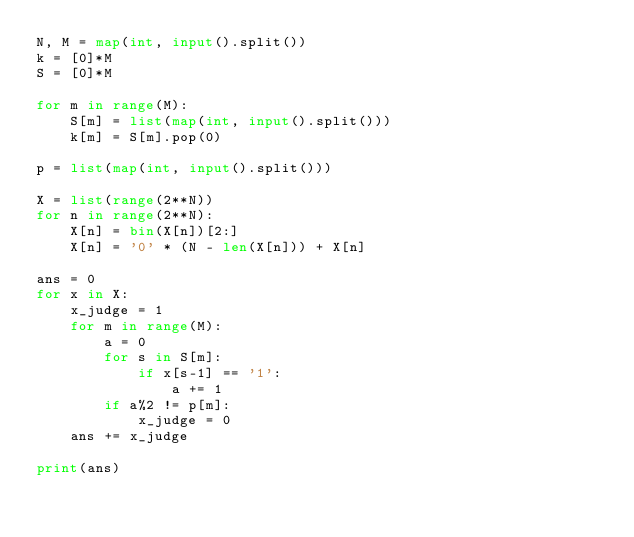<code> <loc_0><loc_0><loc_500><loc_500><_Python_>N, M = map(int, input().split())
k = [0]*M
S = [0]*M

for m in range(M):
    S[m] = list(map(int, input().split()))
    k[m] = S[m].pop(0)

p = list(map(int, input().split()))

X = list(range(2**N))
for n in range(2**N):
    X[n] = bin(X[n])[2:]
    X[n] = '0' * (N - len(X[n])) + X[n]
    
ans = 0
for x in X:
    x_judge = 1
    for m in range(M):
        a = 0
        for s in S[m]:
            if x[s-1] == '1':
                a += 1
        if a%2 != p[m]:
            x_judge = 0
    ans += x_judge
    
print(ans)</code> 